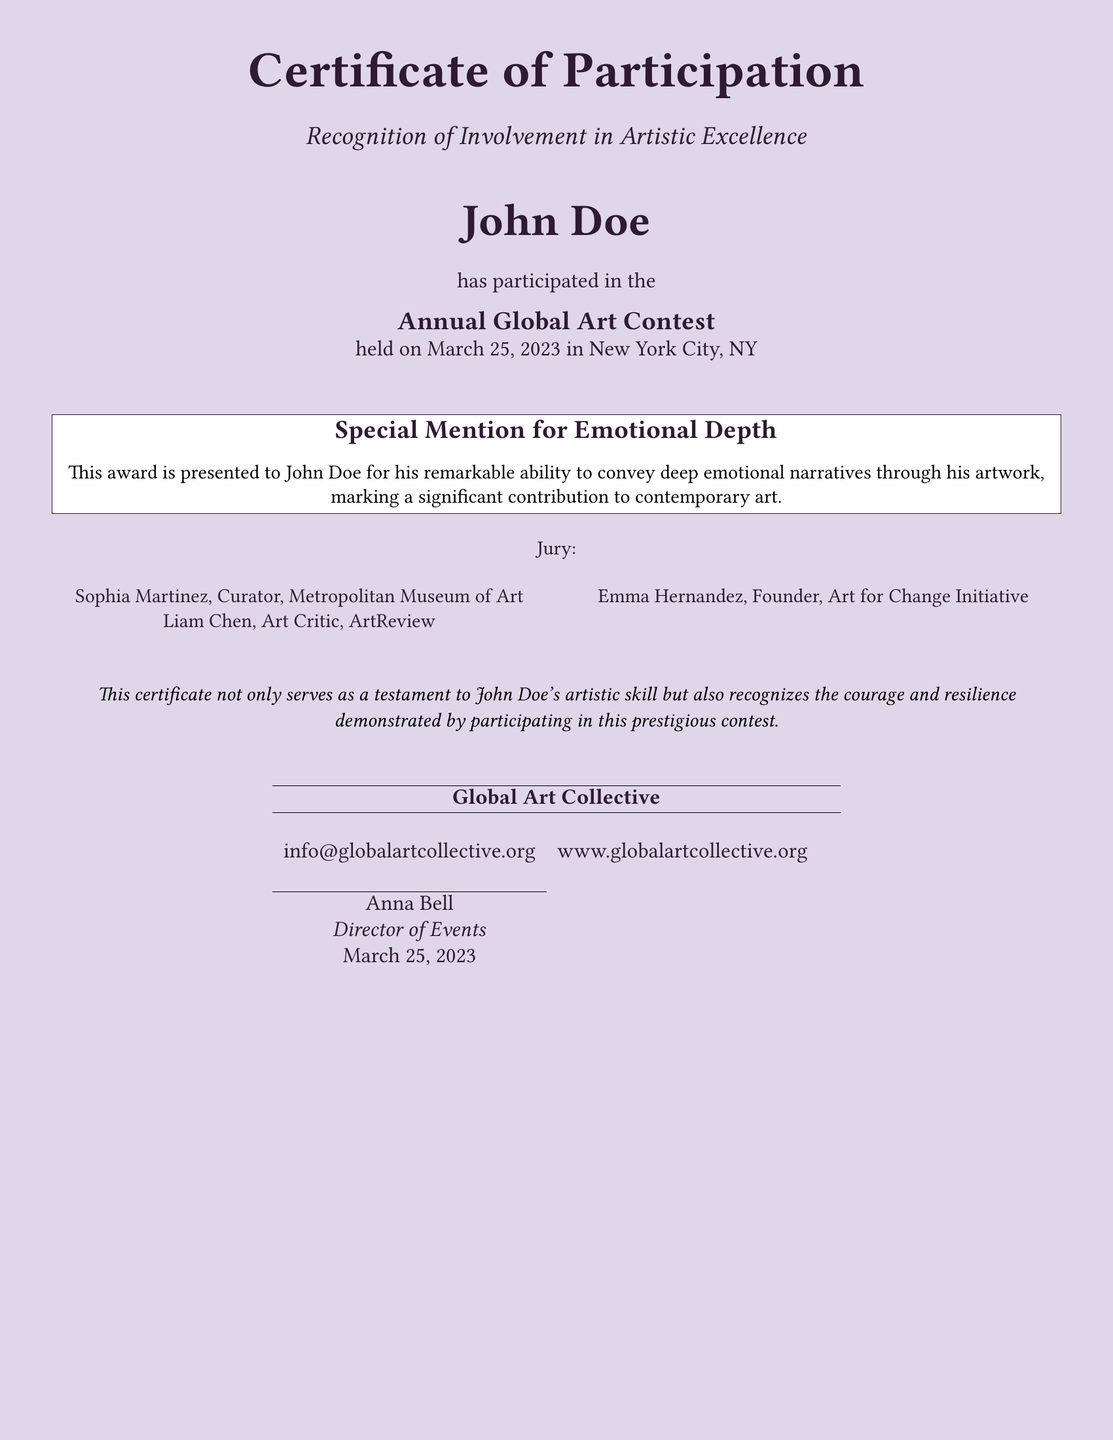What is the title of the document? The title of the document is prominently displayed at the top and is referred to as the Certificate, specifically a Certificate of Participation.
Answer: Certificate of Participation Who is the recipient of the certificate? The name of the individual who received the certificate is clearly mentioned in large font, center-aligned.
Answer: John Doe What event did John Doe participate in? The document specifies the name of the event in the text explaining the participation of John Doe, presented in a part of the body text.
Answer: Annual Global Art Contest What date was the art contest held? The date of the event is provided in the document, located near the event name and associated with John Doe's participation.
Answer: March 25, 2023 Which city hosted the art contest? The city where the contest took place is mentioned directly after the event name in the document.
Answer: New York City, NY What award was given to John Doe? The specific recognition presented to John Doe is highlighted under a special mention section.
Answer: Special Mention for Emotional Depth Who is one of the jury members? The document lists the jury members' names, and one of them can be referenced directly from that section.
Answer: Sophia Martinez What organization issued this certificate? The issuing organization is identified at the bottom of the document, featuring its name.
Answer: Global Art Collective What is the main color theme of the document? The document utilizes a specific color scheme, which is defined in its setting and appearance.
Answer: Light purple What does the certificate recognize beyond artistic skill? The certificate text mentions an additional quality recognized in John Doe, indicating broader significance of participation.
Answer: Courage and resilience 